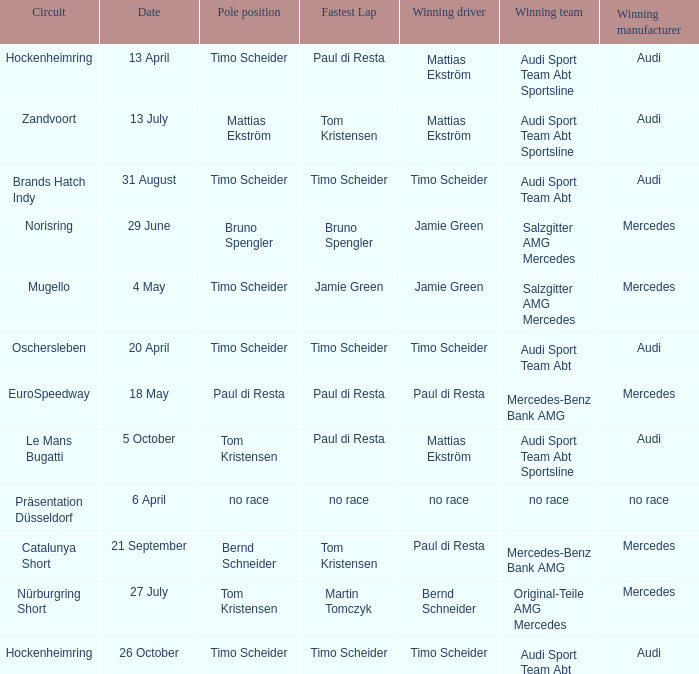Who is the winning driver of the race with no race as the winning manufacturer? No race. 